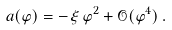<formula> <loc_0><loc_0><loc_500><loc_500>a ( \varphi ) = - \, \xi \, \varphi ^ { 2 } + { \mathcal { O } } ( \varphi ^ { 4 } ) \, .</formula> 